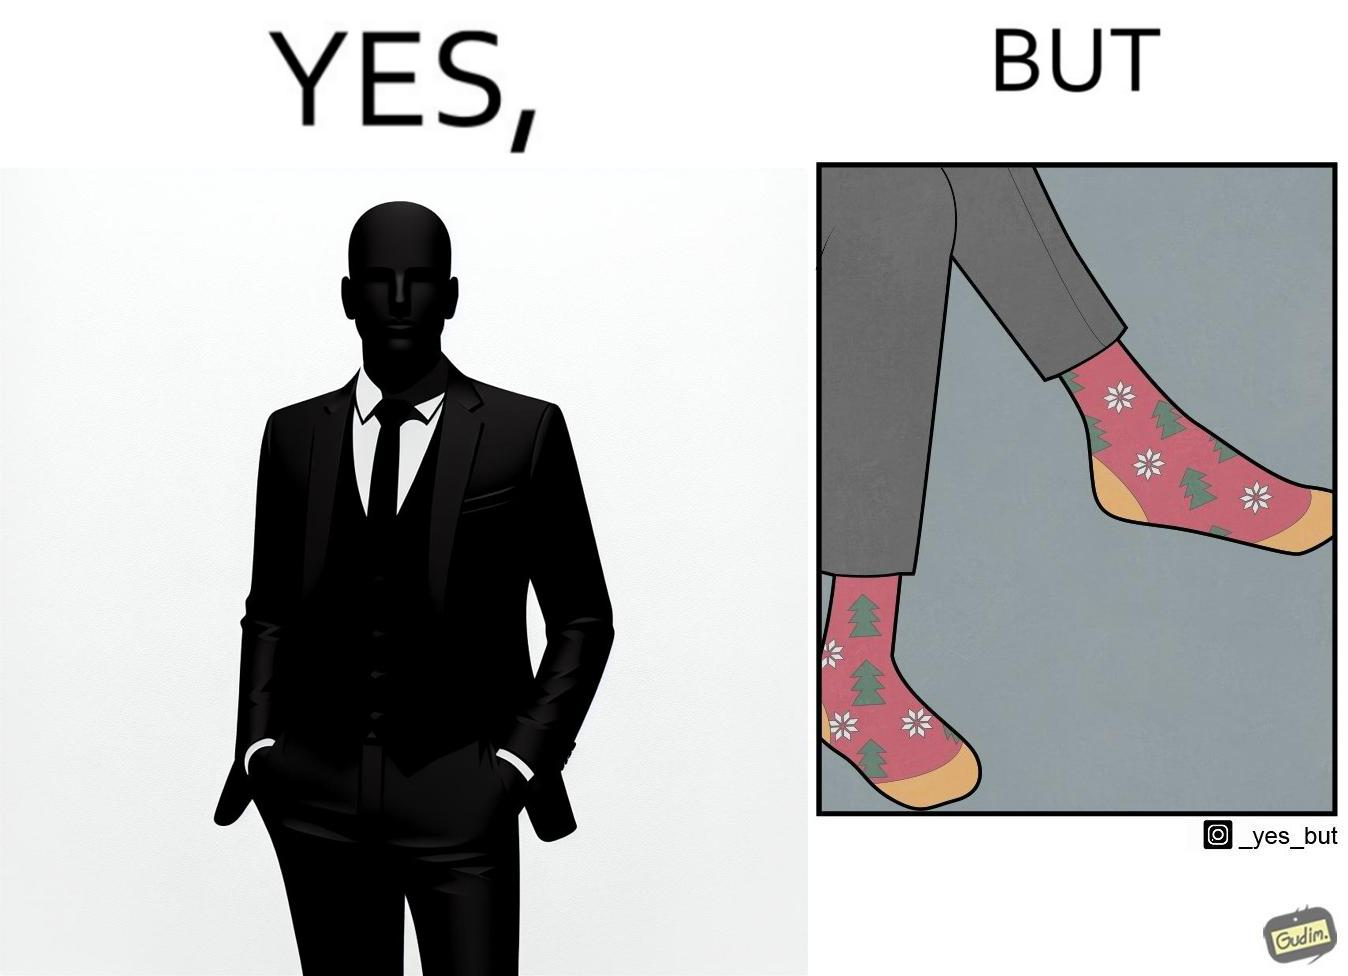Is there satirical content in this image? Yes, this image is satirical. 